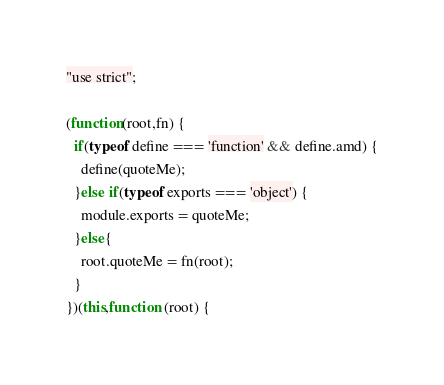<code> <loc_0><loc_0><loc_500><loc_500><_JavaScript_>"use strict";

(function(root,fn) {
  if(typeof define === 'function' && define.amd) {
    define(quoteMe);
  }else if(typeof exports === 'object') {
    module.exports = quoteMe;
  }else{
    root.quoteMe = fn(root);
  }
})(this,function (root) {</code> 